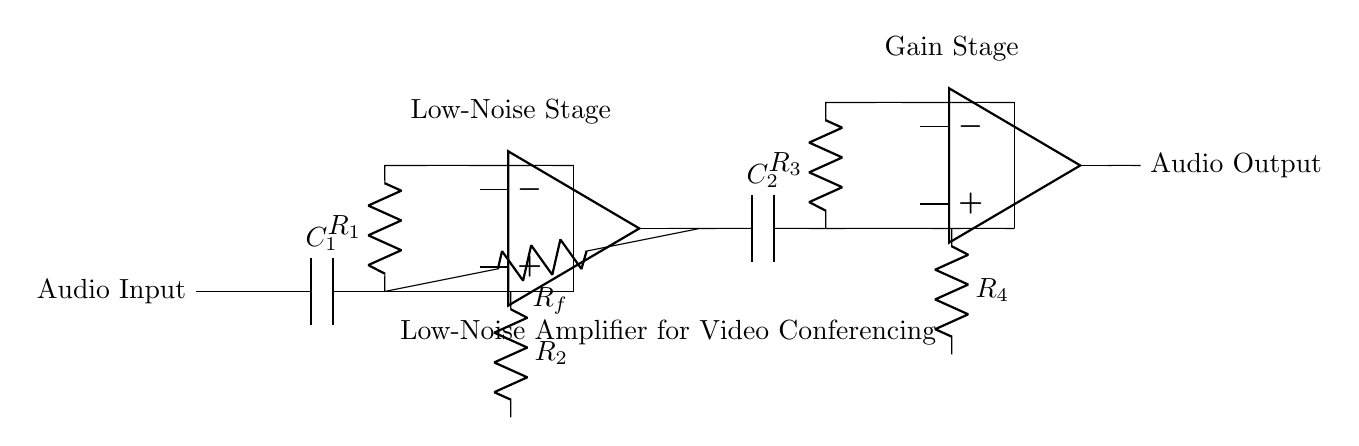What is the purpose of C1 in this circuit? C1 acts as a coupling capacitor, blocking DC components and allowing AC audio signals to pass through, which is essential for audio signal processing.
Answer: Coupling capacitor What is the total number of resistors in this circuit? Counting the resistors labeled R1, R2, R3, and R4, we find there are four resistors in total present in the circuit diagram.
Answer: Four What is the configuration of the operational amplifiers? The two operational amplifiers are configured in series, with the first one acting as a low-noise amplifier and the second one as a gain stage to enhance the audio signal further.
Answer: Series What is the role of Rf in the circuit? Rf functions as a feedback resistor, influencing the gain of the first operational amplifier by setting the ratio of the output voltage to the feedback voltage.
Answer: Feedback resistor What type of amplifier is depicted in this circuit? The circuit is a low-noise amplifier specifically designed for improving audio quality in video conferencing systems, ensuring minimal noise and distortion.
Answer: Low-noise amplifier What components are connected to the output of the second op-amp in this circuit? The output of the second operational amplifier connects directly to the audio output node, which is the point where the amplified audio signal is made available for further processing or output.
Answer: Audio output 